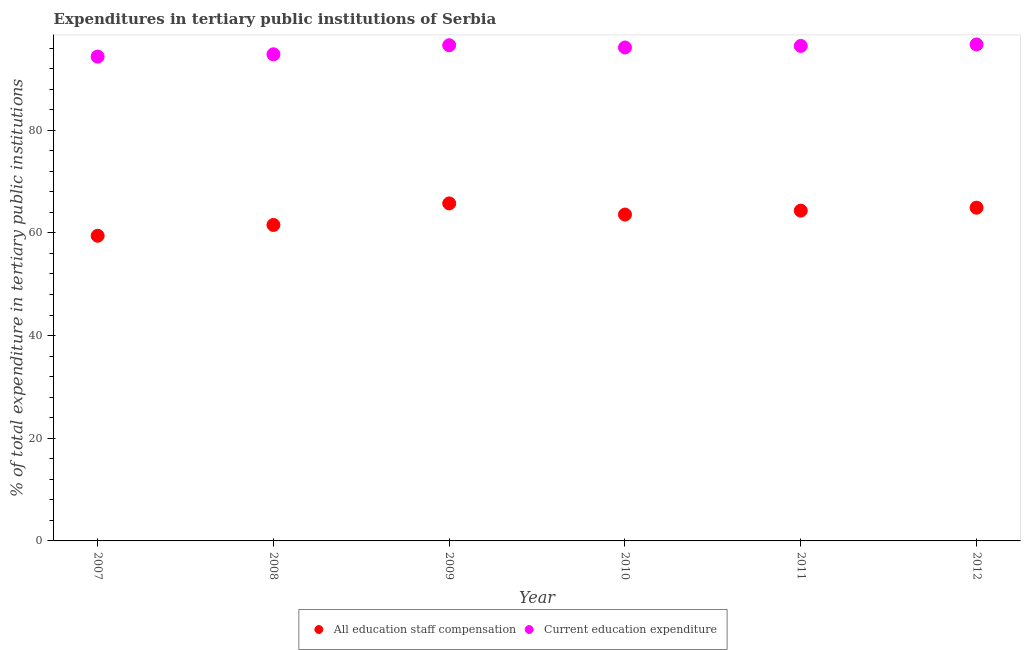What is the expenditure in education in 2009?
Your answer should be compact. 96.55. Across all years, what is the maximum expenditure in staff compensation?
Your answer should be very brief. 65.74. Across all years, what is the minimum expenditure in staff compensation?
Offer a terse response. 59.44. In which year was the expenditure in education maximum?
Make the answer very short. 2012. In which year was the expenditure in staff compensation minimum?
Give a very brief answer. 2007. What is the total expenditure in staff compensation in the graph?
Offer a terse response. 379.54. What is the difference between the expenditure in education in 2009 and that in 2010?
Provide a short and direct response. 0.44. What is the difference between the expenditure in staff compensation in 2010 and the expenditure in education in 2009?
Provide a short and direct response. -32.98. What is the average expenditure in staff compensation per year?
Provide a succinct answer. 63.26. In the year 2012, what is the difference between the expenditure in staff compensation and expenditure in education?
Make the answer very short. -31.8. In how many years, is the expenditure in education greater than 76 %?
Provide a succinct answer. 6. What is the ratio of the expenditure in education in 2007 to that in 2009?
Provide a succinct answer. 0.98. Is the expenditure in education in 2010 less than that in 2011?
Ensure brevity in your answer.  Yes. What is the difference between the highest and the second highest expenditure in staff compensation?
Offer a very short reply. 0.83. What is the difference between the highest and the lowest expenditure in education?
Make the answer very short. 2.37. Is the sum of the expenditure in education in 2009 and 2012 greater than the maximum expenditure in staff compensation across all years?
Give a very brief answer. Yes. Is the expenditure in staff compensation strictly less than the expenditure in education over the years?
Your answer should be very brief. Yes. How many dotlines are there?
Keep it short and to the point. 2. How many years are there in the graph?
Ensure brevity in your answer.  6. Are the values on the major ticks of Y-axis written in scientific E-notation?
Give a very brief answer. No. How many legend labels are there?
Offer a terse response. 2. What is the title of the graph?
Ensure brevity in your answer.  Expenditures in tertiary public institutions of Serbia. Does "Foreign Liabilities" appear as one of the legend labels in the graph?
Your response must be concise. No. What is the label or title of the X-axis?
Provide a succinct answer. Year. What is the label or title of the Y-axis?
Offer a very short reply. % of total expenditure in tertiary public institutions. What is the % of total expenditure in tertiary public institutions in All education staff compensation in 2007?
Provide a succinct answer. 59.44. What is the % of total expenditure in tertiary public institutions of Current education expenditure in 2007?
Keep it short and to the point. 94.34. What is the % of total expenditure in tertiary public institutions of All education staff compensation in 2008?
Keep it short and to the point. 61.55. What is the % of total expenditure in tertiary public institutions of Current education expenditure in 2008?
Your answer should be compact. 94.79. What is the % of total expenditure in tertiary public institutions in All education staff compensation in 2009?
Offer a very short reply. 65.74. What is the % of total expenditure in tertiary public institutions of Current education expenditure in 2009?
Your answer should be very brief. 96.55. What is the % of total expenditure in tertiary public institutions of All education staff compensation in 2010?
Make the answer very short. 63.57. What is the % of total expenditure in tertiary public institutions in Current education expenditure in 2010?
Offer a terse response. 96.12. What is the % of total expenditure in tertiary public institutions of All education staff compensation in 2011?
Give a very brief answer. 64.33. What is the % of total expenditure in tertiary public institutions in Current education expenditure in 2011?
Ensure brevity in your answer.  96.42. What is the % of total expenditure in tertiary public institutions in All education staff compensation in 2012?
Provide a short and direct response. 64.91. What is the % of total expenditure in tertiary public institutions of Current education expenditure in 2012?
Offer a terse response. 96.71. Across all years, what is the maximum % of total expenditure in tertiary public institutions in All education staff compensation?
Your answer should be very brief. 65.74. Across all years, what is the maximum % of total expenditure in tertiary public institutions in Current education expenditure?
Provide a short and direct response. 96.71. Across all years, what is the minimum % of total expenditure in tertiary public institutions in All education staff compensation?
Offer a terse response. 59.44. Across all years, what is the minimum % of total expenditure in tertiary public institutions in Current education expenditure?
Your response must be concise. 94.34. What is the total % of total expenditure in tertiary public institutions in All education staff compensation in the graph?
Offer a terse response. 379.54. What is the total % of total expenditure in tertiary public institutions of Current education expenditure in the graph?
Make the answer very short. 574.92. What is the difference between the % of total expenditure in tertiary public institutions of All education staff compensation in 2007 and that in 2008?
Your answer should be very brief. -2.11. What is the difference between the % of total expenditure in tertiary public institutions of Current education expenditure in 2007 and that in 2008?
Offer a terse response. -0.45. What is the difference between the % of total expenditure in tertiary public institutions in All education staff compensation in 2007 and that in 2009?
Provide a succinct answer. -6.3. What is the difference between the % of total expenditure in tertiary public institutions in Current education expenditure in 2007 and that in 2009?
Provide a short and direct response. -2.21. What is the difference between the % of total expenditure in tertiary public institutions in All education staff compensation in 2007 and that in 2010?
Your answer should be compact. -4.13. What is the difference between the % of total expenditure in tertiary public institutions in Current education expenditure in 2007 and that in 2010?
Give a very brief answer. -1.77. What is the difference between the % of total expenditure in tertiary public institutions in All education staff compensation in 2007 and that in 2011?
Provide a short and direct response. -4.89. What is the difference between the % of total expenditure in tertiary public institutions of Current education expenditure in 2007 and that in 2011?
Offer a terse response. -2.07. What is the difference between the % of total expenditure in tertiary public institutions in All education staff compensation in 2007 and that in 2012?
Your response must be concise. -5.47. What is the difference between the % of total expenditure in tertiary public institutions in Current education expenditure in 2007 and that in 2012?
Provide a succinct answer. -2.37. What is the difference between the % of total expenditure in tertiary public institutions in All education staff compensation in 2008 and that in 2009?
Offer a very short reply. -4.19. What is the difference between the % of total expenditure in tertiary public institutions in Current education expenditure in 2008 and that in 2009?
Keep it short and to the point. -1.77. What is the difference between the % of total expenditure in tertiary public institutions in All education staff compensation in 2008 and that in 2010?
Your answer should be very brief. -2.03. What is the difference between the % of total expenditure in tertiary public institutions of Current education expenditure in 2008 and that in 2010?
Give a very brief answer. -1.33. What is the difference between the % of total expenditure in tertiary public institutions of All education staff compensation in 2008 and that in 2011?
Give a very brief answer. -2.79. What is the difference between the % of total expenditure in tertiary public institutions in Current education expenditure in 2008 and that in 2011?
Make the answer very short. -1.63. What is the difference between the % of total expenditure in tertiary public institutions of All education staff compensation in 2008 and that in 2012?
Offer a very short reply. -3.36. What is the difference between the % of total expenditure in tertiary public institutions in Current education expenditure in 2008 and that in 2012?
Ensure brevity in your answer.  -1.92. What is the difference between the % of total expenditure in tertiary public institutions of All education staff compensation in 2009 and that in 2010?
Give a very brief answer. 2.17. What is the difference between the % of total expenditure in tertiary public institutions in Current education expenditure in 2009 and that in 2010?
Provide a short and direct response. 0.44. What is the difference between the % of total expenditure in tertiary public institutions in All education staff compensation in 2009 and that in 2011?
Offer a terse response. 1.41. What is the difference between the % of total expenditure in tertiary public institutions in Current education expenditure in 2009 and that in 2011?
Provide a short and direct response. 0.14. What is the difference between the % of total expenditure in tertiary public institutions of All education staff compensation in 2009 and that in 2012?
Offer a very short reply. 0.83. What is the difference between the % of total expenditure in tertiary public institutions in Current education expenditure in 2009 and that in 2012?
Your response must be concise. -0.16. What is the difference between the % of total expenditure in tertiary public institutions in All education staff compensation in 2010 and that in 2011?
Your response must be concise. -0.76. What is the difference between the % of total expenditure in tertiary public institutions in Current education expenditure in 2010 and that in 2011?
Your answer should be compact. -0.3. What is the difference between the % of total expenditure in tertiary public institutions of All education staff compensation in 2010 and that in 2012?
Your answer should be compact. -1.33. What is the difference between the % of total expenditure in tertiary public institutions of Current education expenditure in 2010 and that in 2012?
Your response must be concise. -0.59. What is the difference between the % of total expenditure in tertiary public institutions in All education staff compensation in 2011 and that in 2012?
Your answer should be compact. -0.57. What is the difference between the % of total expenditure in tertiary public institutions in Current education expenditure in 2011 and that in 2012?
Your answer should be very brief. -0.29. What is the difference between the % of total expenditure in tertiary public institutions of All education staff compensation in 2007 and the % of total expenditure in tertiary public institutions of Current education expenditure in 2008?
Offer a terse response. -35.35. What is the difference between the % of total expenditure in tertiary public institutions in All education staff compensation in 2007 and the % of total expenditure in tertiary public institutions in Current education expenditure in 2009?
Make the answer very short. -37.11. What is the difference between the % of total expenditure in tertiary public institutions of All education staff compensation in 2007 and the % of total expenditure in tertiary public institutions of Current education expenditure in 2010?
Offer a very short reply. -36.68. What is the difference between the % of total expenditure in tertiary public institutions in All education staff compensation in 2007 and the % of total expenditure in tertiary public institutions in Current education expenditure in 2011?
Offer a terse response. -36.97. What is the difference between the % of total expenditure in tertiary public institutions in All education staff compensation in 2007 and the % of total expenditure in tertiary public institutions in Current education expenditure in 2012?
Give a very brief answer. -37.27. What is the difference between the % of total expenditure in tertiary public institutions in All education staff compensation in 2008 and the % of total expenditure in tertiary public institutions in Current education expenditure in 2009?
Give a very brief answer. -35.01. What is the difference between the % of total expenditure in tertiary public institutions of All education staff compensation in 2008 and the % of total expenditure in tertiary public institutions of Current education expenditure in 2010?
Provide a succinct answer. -34.57. What is the difference between the % of total expenditure in tertiary public institutions in All education staff compensation in 2008 and the % of total expenditure in tertiary public institutions in Current education expenditure in 2011?
Provide a succinct answer. -34.87. What is the difference between the % of total expenditure in tertiary public institutions in All education staff compensation in 2008 and the % of total expenditure in tertiary public institutions in Current education expenditure in 2012?
Your response must be concise. -35.16. What is the difference between the % of total expenditure in tertiary public institutions in All education staff compensation in 2009 and the % of total expenditure in tertiary public institutions in Current education expenditure in 2010?
Provide a succinct answer. -30.37. What is the difference between the % of total expenditure in tertiary public institutions in All education staff compensation in 2009 and the % of total expenditure in tertiary public institutions in Current education expenditure in 2011?
Your response must be concise. -30.67. What is the difference between the % of total expenditure in tertiary public institutions in All education staff compensation in 2009 and the % of total expenditure in tertiary public institutions in Current education expenditure in 2012?
Give a very brief answer. -30.97. What is the difference between the % of total expenditure in tertiary public institutions in All education staff compensation in 2010 and the % of total expenditure in tertiary public institutions in Current education expenditure in 2011?
Make the answer very short. -32.84. What is the difference between the % of total expenditure in tertiary public institutions in All education staff compensation in 2010 and the % of total expenditure in tertiary public institutions in Current education expenditure in 2012?
Your response must be concise. -33.13. What is the difference between the % of total expenditure in tertiary public institutions in All education staff compensation in 2011 and the % of total expenditure in tertiary public institutions in Current education expenditure in 2012?
Give a very brief answer. -32.38. What is the average % of total expenditure in tertiary public institutions in All education staff compensation per year?
Keep it short and to the point. 63.26. What is the average % of total expenditure in tertiary public institutions of Current education expenditure per year?
Provide a succinct answer. 95.82. In the year 2007, what is the difference between the % of total expenditure in tertiary public institutions in All education staff compensation and % of total expenditure in tertiary public institutions in Current education expenditure?
Provide a succinct answer. -34.9. In the year 2008, what is the difference between the % of total expenditure in tertiary public institutions of All education staff compensation and % of total expenditure in tertiary public institutions of Current education expenditure?
Offer a terse response. -33.24. In the year 2009, what is the difference between the % of total expenditure in tertiary public institutions of All education staff compensation and % of total expenditure in tertiary public institutions of Current education expenditure?
Provide a succinct answer. -30.81. In the year 2010, what is the difference between the % of total expenditure in tertiary public institutions of All education staff compensation and % of total expenditure in tertiary public institutions of Current education expenditure?
Your response must be concise. -32.54. In the year 2011, what is the difference between the % of total expenditure in tertiary public institutions of All education staff compensation and % of total expenditure in tertiary public institutions of Current education expenditure?
Offer a terse response. -32.08. In the year 2012, what is the difference between the % of total expenditure in tertiary public institutions in All education staff compensation and % of total expenditure in tertiary public institutions in Current education expenditure?
Offer a very short reply. -31.8. What is the ratio of the % of total expenditure in tertiary public institutions of All education staff compensation in 2007 to that in 2008?
Keep it short and to the point. 0.97. What is the ratio of the % of total expenditure in tertiary public institutions of Current education expenditure in 2007 to that in 2008?
Your answer should be compact. 1. What is the ratio of the % of total expenditure in tertiary public institutions of All education staff compensation in 2007 to that in 2009?
Your answer should be very brief. 0.9. What is the ratio of the % of total expenditure in tertiary public institutions of Current education expenditure in 2007 to that in 2009?
Offer a terse response. 0.98. What is the ratio of the % of total expenditure in tertiary public institutions in All education staff compensation in 2007 to that in 2010?
Keep it short and to the point. 0.94. What is the ratio of the % of total expenditure in tertiary public institutions of Current education expenditure in 2007 to that in 2010?
Keep it short and to the point. 0.98. What is the ratio of the % of total expenditure in tertiary public institutions of All education staff compensation in 2007 to that in 2011?
Give a very brief answer. 0.92. What is the ratio of the % of total expenditure in tertiary public institutions in Current education expenditure in 2007 to that in 2011?
Your answer should be compact. 0.98. What is the ratio of the % of total expenditure in tertiary public institutions in All education staff compensation in 2007 to that in 2012?
Keep it short and to the point. 0.92. What is the ratio of the % of total expenditure in tertiary public institutions in Current education expenditure in 2007 to that in 2012?
Keep it short and to the point. 0.98. What is the ratio of the % of total expenditure in tertiary public institutions of All education staff compensation in 2008 to that in 2009?
Give a very brief answer. 0.94. What is the ratio of the % of total expenditure in tertiary public institutions of Current education expenditure in 2008 to that in 2009?
Offer a very short reply. 0.98. What is the ratio of the % of total expenditure in tertiary public institutions in All education staff compensation in 2008 to that in 2010?
Make the answer very short. 0.97. What is the ratio of the % of total expenditure in tertiary public institutions in Current education expenditure in 2008 to that in 2010?
Provide a short and direct response. 0.99. What is the ratio of the % of total expenditure in tertiary public institutions of All education staff compensation in 2008 to that in 2011?
Offer a very short reply. 0.96. What is the ratio of the % of total expenditure in tertiary public institutions in Current education expenditure in 2008 to that in 2011?
Your response must be concise. 0.98. What is the ratio of the % of total expenditure in tertiary public institutions in All education staff compensation in 2008 to that in 2012?
Offer a terse response. 0.95. What is the ratio of the % of total expenditure in tertiary public institutions in Current education expenditure in 2008 to that in 2012?
Offer a terse response. 0.98. What is the ratio of the % of total expenditure in tertiary public institutions of All education staff compensation in 2009 to that in 2010?
Keep it short and to the point. 1.03. What is the ratio of the % of total expenditure in tertiary public institutions of Current education expenditure in 2009 to that in 2010?
Make the answer very short. 1. What is the ratio of the % of total expenditure in tertiary public institutions of All education staff compensation in 2009 to that in 2011?
Give a very brief answer. 1.02. What is the ratio of the % of total expenditure in tertiary public institutions of All education staff compensation in 2009 to that in 2012?
Make the answer very short. 1.01. What is the ratio of the % of total expenditure in tertiary public institutions in All education staff compensation in 2010 to that in 2011?
Keep it short and to the point. 0.99. What is the ratio of the % of total expenditure in tertiary public institutions of All education staff compensation in 2010 to that in 2012?
Ensure brevity in your answer.  0.98. What is the ratio of the % of total expenditure in tertiary public institutions in Current education expenditure in 2010 to that in 2012?
Ensure brevity in your answer.  0.99. What is the ratio of the % of total expenditure in tertiary public institutions of All education staff compensation in 2011 to that in 2012?
Your response must be concise. 0.99. What is the ratio of the % of total expenditure in tertiary public institutions in Current education expenditure in 2011 to that in 2012?
Keep it short and to the point. 1. What is the difference between the highest and the second highest % of total expenditure in tertiary public institutions of All education staff compensation?
Make the answer very short. 0.83. What is the difference between the highest and the second highest % of total expenditure in tertiary public institutions in Current education expenditure?
Your answer should be very brief. 0.16. What is the difference between the highest and the lowest % of total expenditure in tertiary public institutions in All education staff compensation?
Provide a short and direct response. 6.3. What is the difference between the highest and the lowest % of total expenditure in tertiary public institutions in Current education expenditure?
Provide a succinct answer. 2.37. 